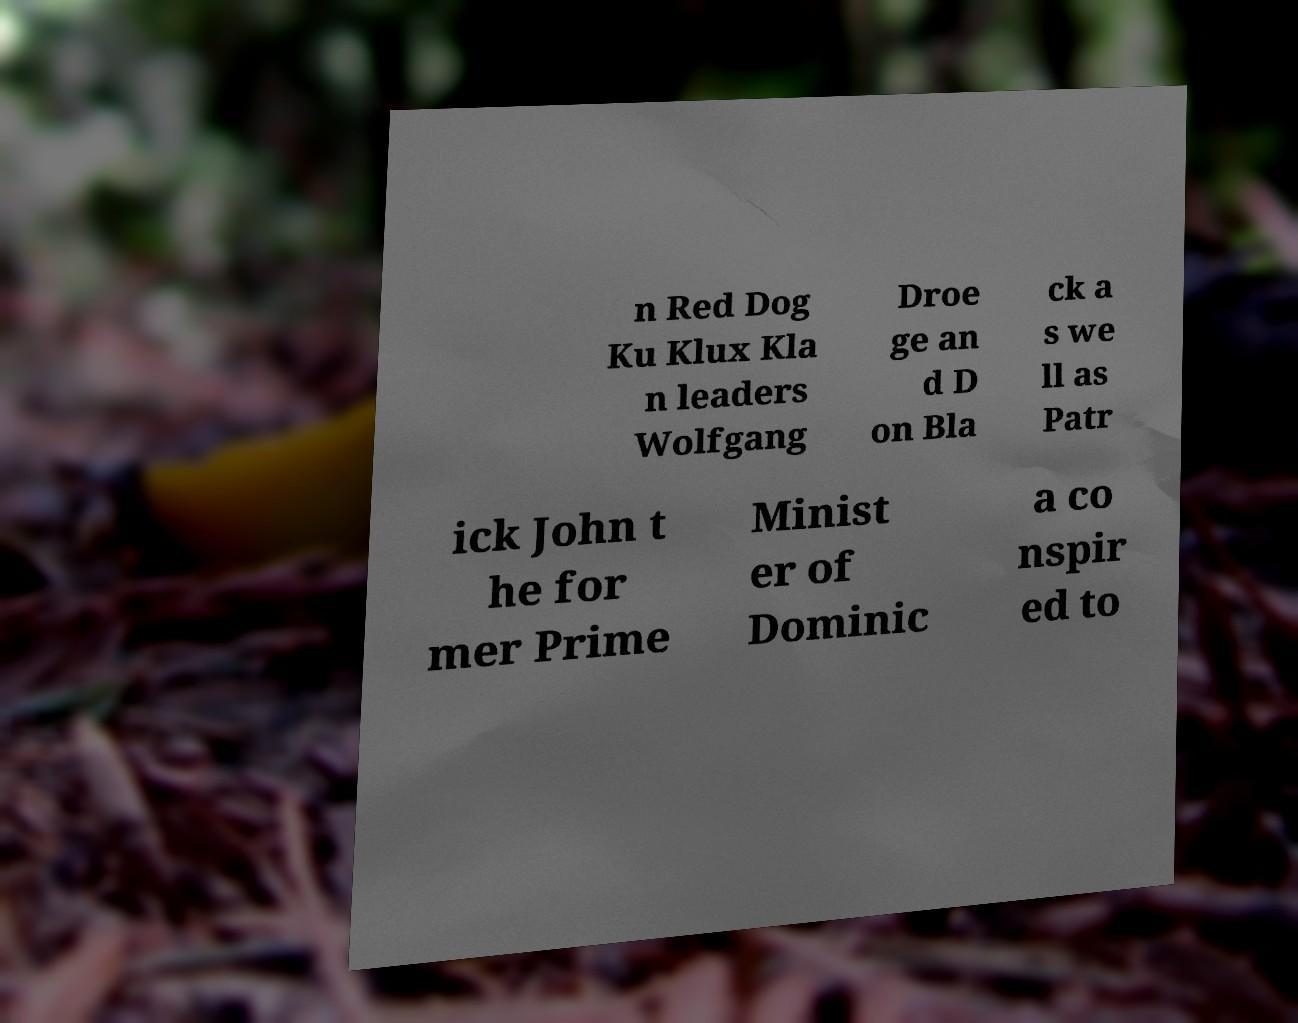Could you extract and type out the text from this image? n Red Dog Ku Klux Kla n leaders Wolfgang Droe ge an d D on Bla ck a s we ll as Patr ick John t he for mer Prime Minist er of Dominic a co nspir ed to 